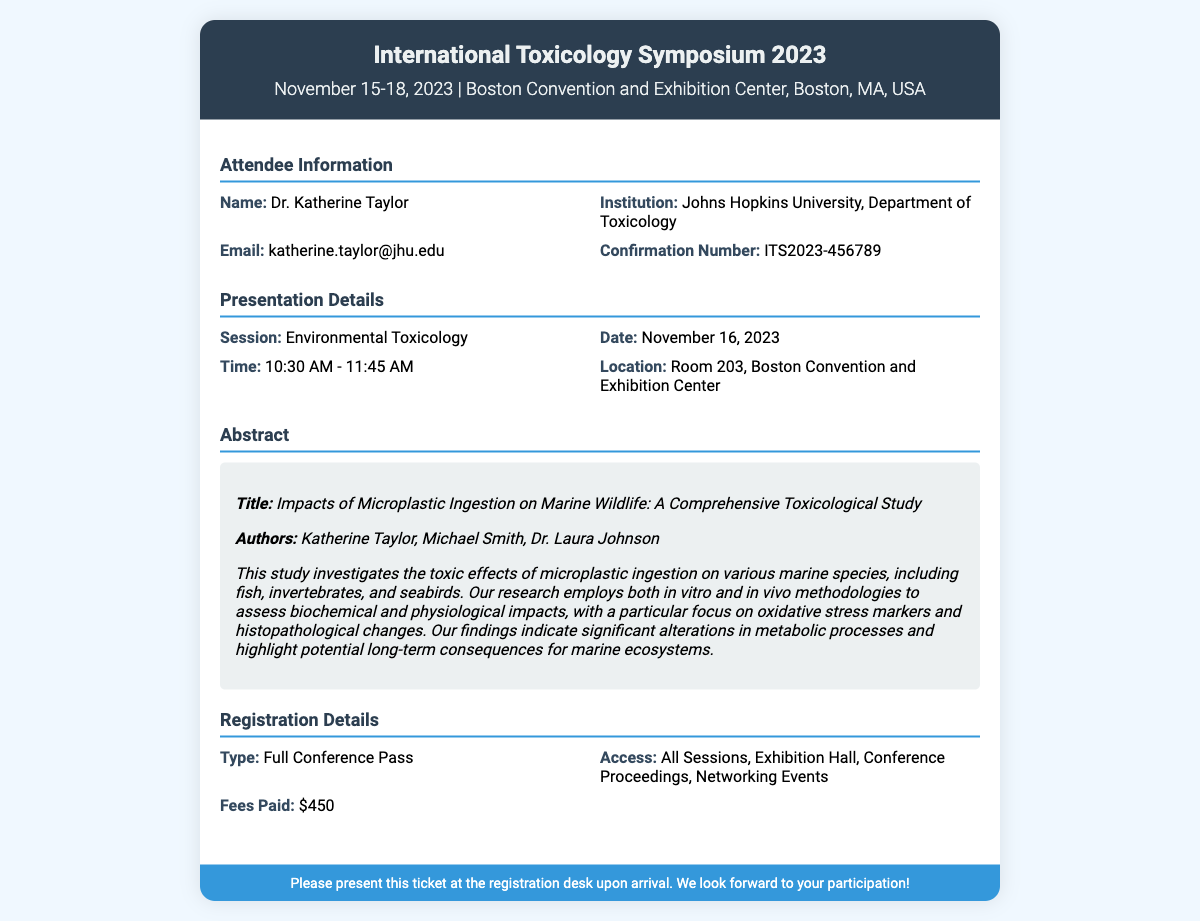What is the name of the attendee? The attendee's name is listed in the document under Attendee Information.
Answer: Dr. Katherine Taylor What is the confirmation number? The confirmation number is found in the Attendee Information section of the document.
Answer: ITS2023-456789 What is the title of the abstract? The title of the abstract can be found in the Abstract section of the document.
Answer: Impacts of Microplastic Ingestion on Marine Wildlife: A Comprehensive Toxicological Study When is the presentation scheduled? The date of the presentation is provided in the Presentation Details section.
Answer: November 16, 2023 What session is the presentation part of? The session for the presentation is mentioned in the Presentation Details section.
Answer: Environmental Toxicology What are the fees paid for the registration? The fees paid are listed in the Registration Details section of the document.
Answer: $450 Which institution does the attendee represent? The institution of the attendee is specified in the Attendee Information section.
Answer: Johns Hopkins University, Department of Toxicology What type of ticket does the attendee have? The type of registration is detailed in the Registration Details section of the document.
Answer: Full Conference Pass What is the time of the presentation? The time of the presentation is mentioned in the Presentation Details section.
Answer: 10:30 AM - 11:45 AM 